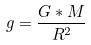Convert formula to latex. <formula><loc_0><loc_0><loc_500><loc_500>g = \frac { G * M } { R ^ { 2 } }</formula> 